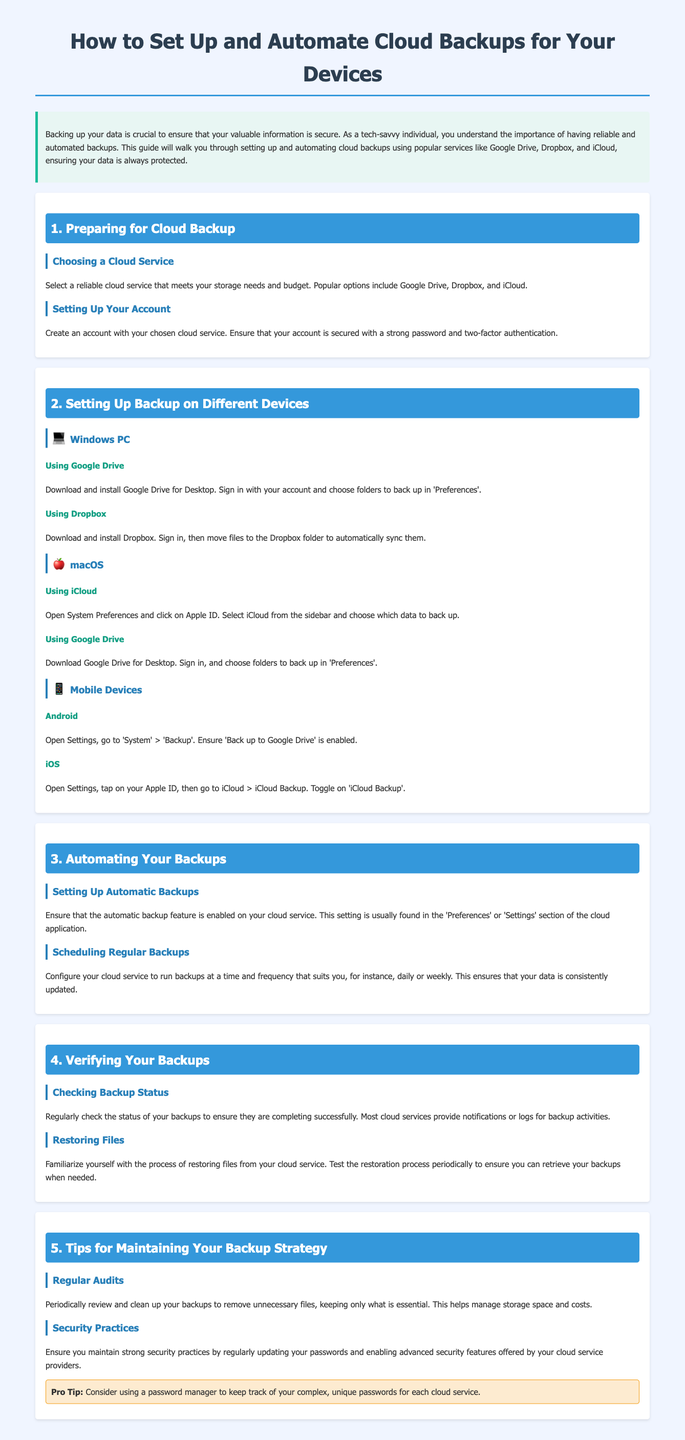What is the title of the guide? The title of the guide is displayed prominently at the top of the document, indicating the main topic it covers.
Answer: How to Set Up and Automate Cloud Backups for Your Devices What cloud services are mentioned for backups? The document lists the specific cloud services that are popular for backups in the introduction and the device sections.
Answer: Google Drive, Dropbox, iCloud Which operating system does the guide provide instructions for using iCloud? The guide specifies which devices the instructions apply to, particularly for iCloud usage.
Answer: macOS How often should backups be scheduled according to the document? The guide suggests scheduling backups at a frequency that is suitable for users, which is mentioned under automating your backups.
Answer: Daily or weekly What is a pro tip provided in the guide? The document includes a tip section offering useful advice regarding managing passwords for cloud services.
Answer: Consider using a password manager What should you periodically do with your backups? The document emphasizes the importance of maintaining your backup strategy by performing certain routine checks.
Answer: Review and clean up What feature should be enabled for automatic backups? The guide highlights a specific feature that needs to be activated for backups to occur without manual intervention.
Answer: Automatic backup feature Which devices are mentioned for Android backup instructions? The guide includes a section dedicated to mobile devices, specifically addressing Android users.
Answer: Mobile Devices 